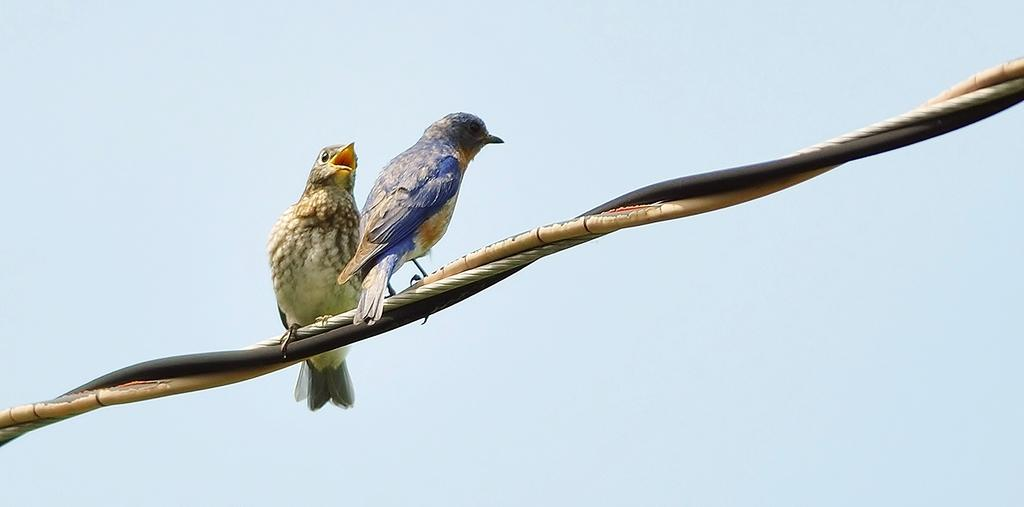What animals are present in the image? There are two birds in the image. What are the birds doing in the image? The birds are standing on a rope. What color is the background of the image? The background of the image is light blue in color. What scientific experiment is being conducted with the birds in the image? There is no indication of a scientific experiment being conducted in the image; the birds are simply standing on a rope. Can you tell me how many grains of powder are visible on the rope in the image? There is no powder visible on the rope in the image. 